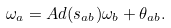Convert formula to latex. <formula><loc_0><loc_0><loc_500><loc_500>\omega _ { a } = A d ( s _ { a b } ) \omega _ { b } + \theta _ { a b } .</formula> 